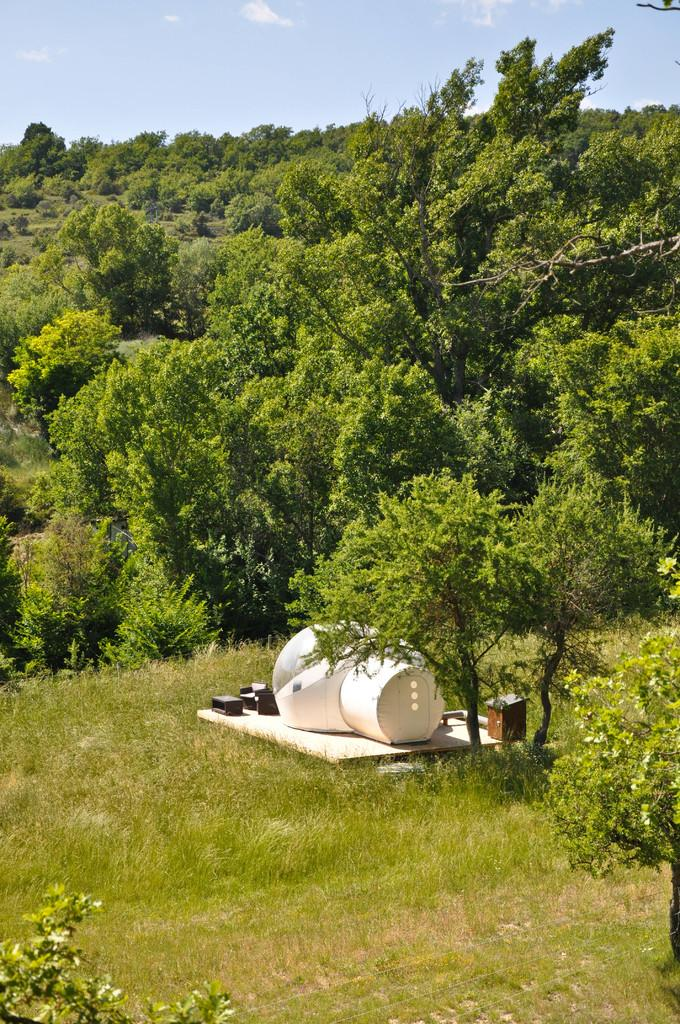What type of vegetation can be seen in the image? There are trees in the image. What else can be seen in the image besides the trees? There are objects and grass visible in the image. What is visible in the background of the image? The sky is visible in the background of the image. Where is the group of people playing with the tub in the image? There is no group of people playing with a tub in the image; it only features trees, objects, grass, and the sky. What type of hair can be seen on the trees in the image? Trees do not have hair; the question is not applicable to the image. 